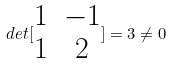Convert formula to latex. <formula><loc_0><loc_0><loc_500><loc_500>d e t [ \begin{matrix} 1 & - 1 \\ 1 & 2 \end{matrix} ] = 3 \ne 0</formula> 